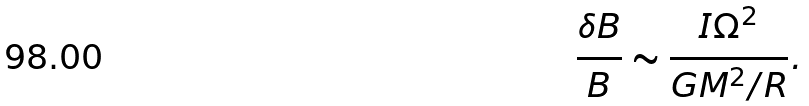Convert formula to latex. <formula><loc_0><loc_0><loc_500><loc_500>\frac { \delta B } { B } \sim \frac { I \Omega ^ { 2 } } { G M ^ { 2 } / R } .</formula> 